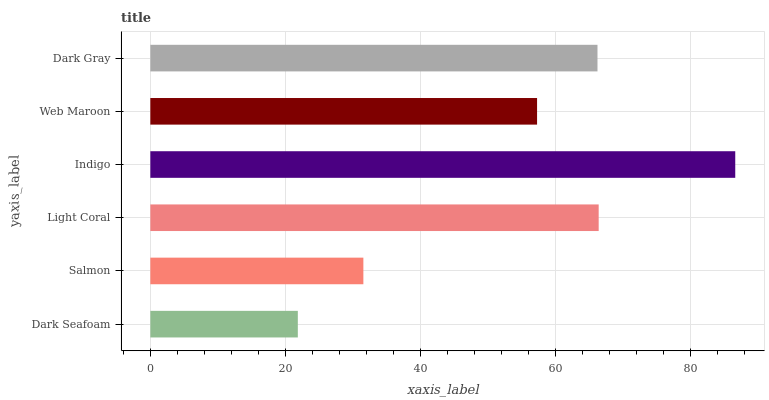Is Dark Seafoam the minimum?
Answer yes or no. Yes. Is Indigo the maximum?
Answer yes or no. Yes. Is Salmon the minimum?
Answer yes or no. No. Is Salmon the maximum?
Answer yes or no. No. Is Salmon greater than Dark Seafoam?
Answer yes or no. Yes. Is Dark Seafoam less than Salmon?
Answer yes or no. Yes. Is Dark Seafoam greater than Salmon?
Answer yes or no. No. Is Salmon less than Dark Seafoam?
Answer yes or no. No. Is Dark Gray the high median?
Answer yes or no. Yes. Is Web Maroon the low median?
Answer yes or no. Yes. Is Web Maroon the high median?
Answer yes or no. No. Is Salmon the low median?
Answer yes or no. No. 